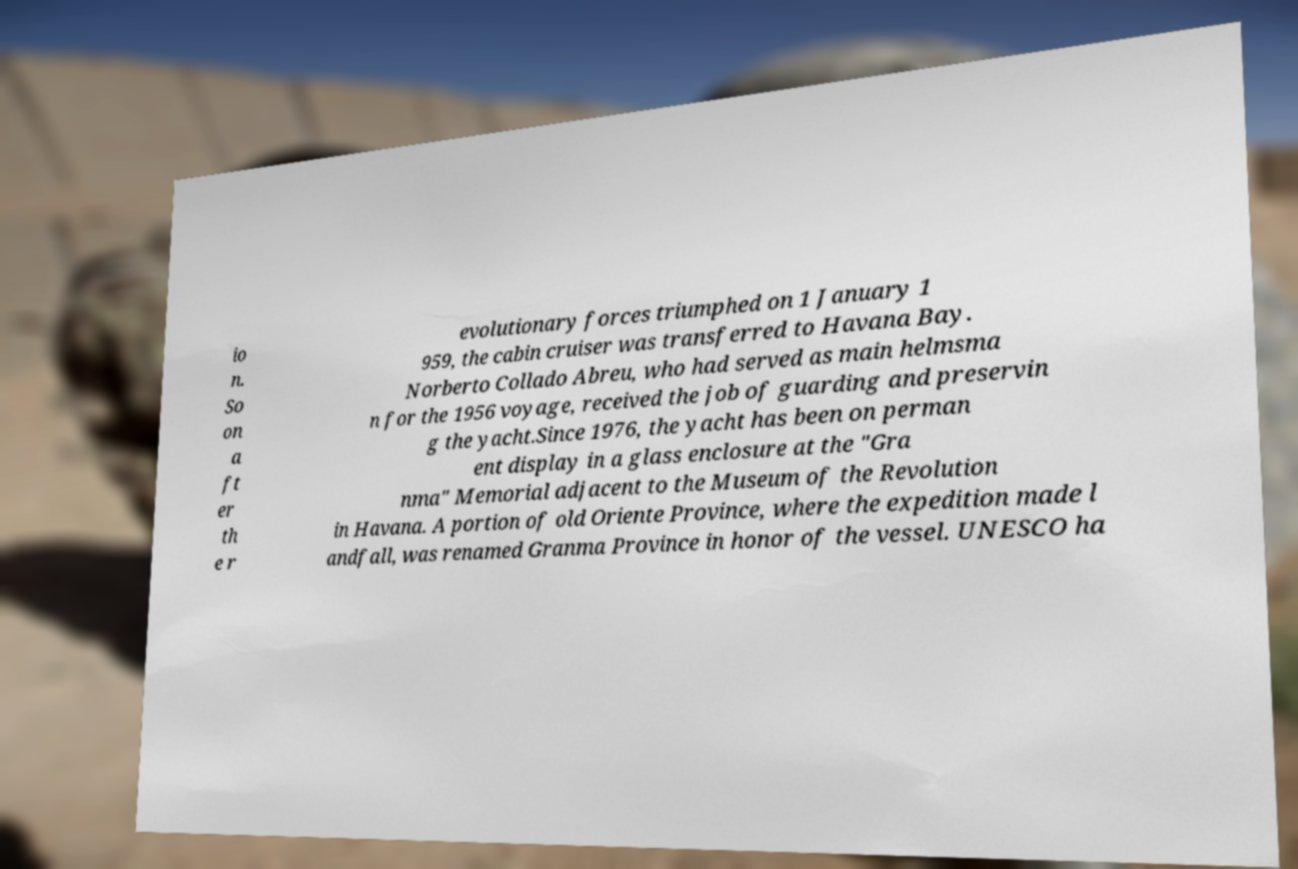Can you accurately transcribe the text from the provided image for me? io n. So on a ft er th e r evolutionary forces triumphed on 1 January 1 959, the cabin cruiser was transferred to Havana Bay. Norberto Collado Abreu, who had served as main helmsma n for the 1956 voyage, received the job of guarding and preservin g the yacht.Since 1976, the yacht has been on perman ent display in a glass enclosure at the "Gra nma" Memorial adjacent to the Museum of the Revolution in Havana. A portion of old Oriente Province, where the expedition made l andfall, was renamed Granma Province in honor of the vessel. UNESCO ha 